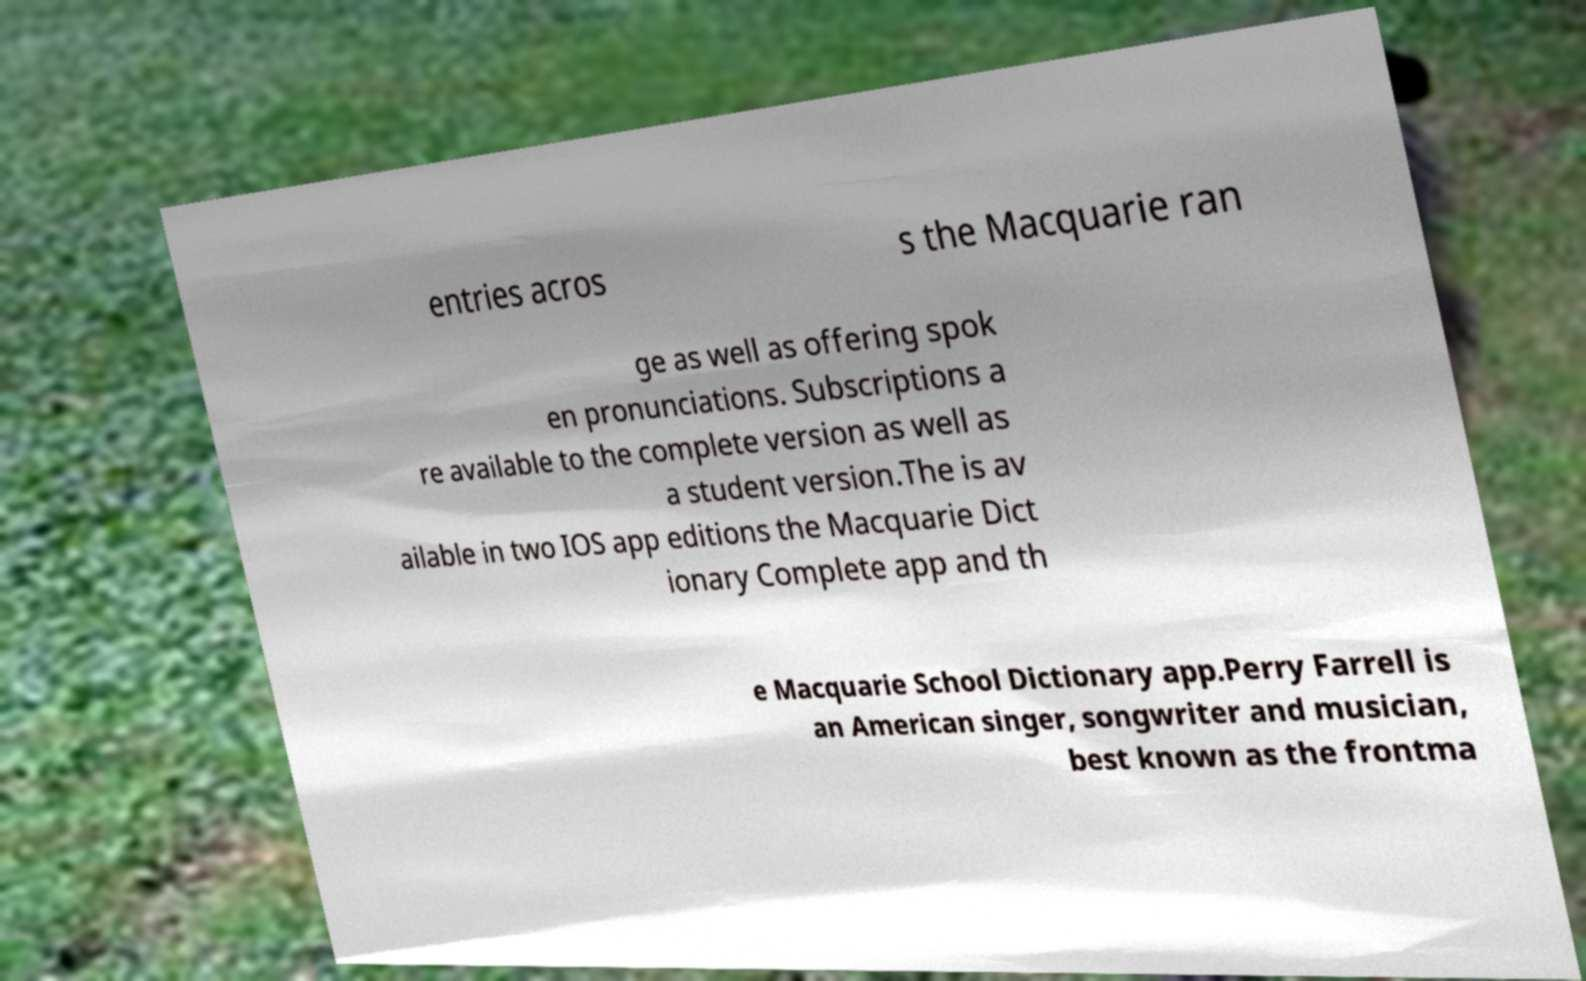For documentation purposes, I need the text within this image transcribed. Could you provide that? entries acros s the Macquarie ran ge as well as offering spok en pronunciations. Subscriptions a re available to the complete version as well as a student version.The is av ailable in two IOS app editions the Macquarie Dict ionary Complete app and th e Macquarie School Dictionary app.Perry Farrell is an American singer, songwriter and musician, best known as the frontma 